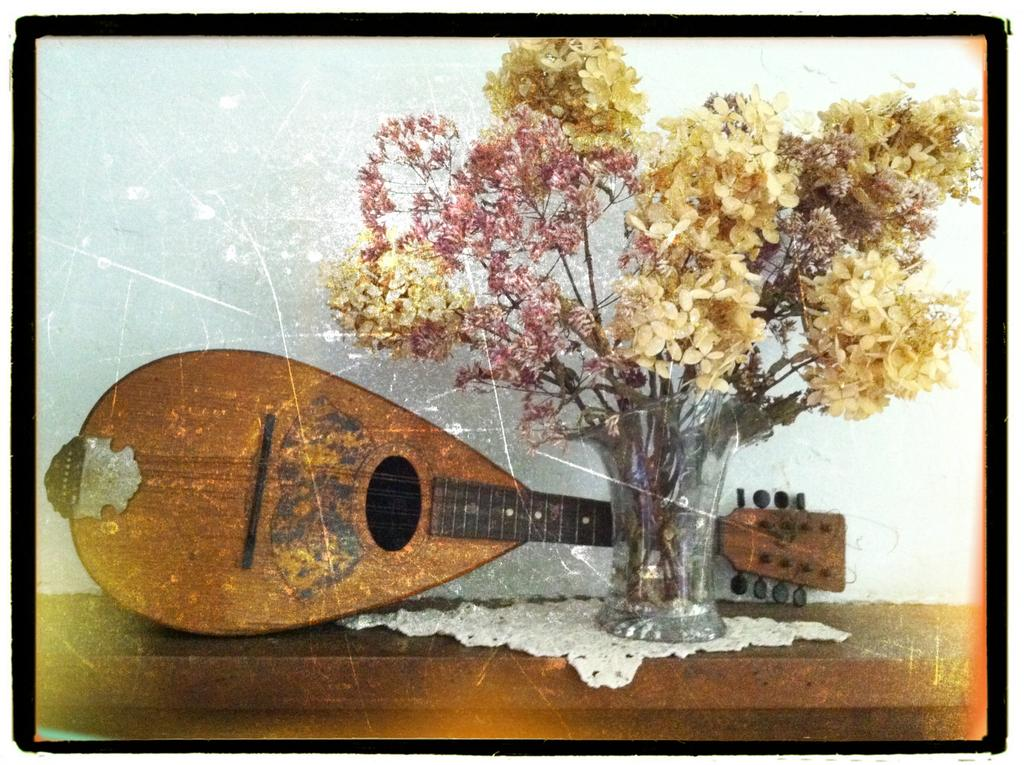What is the main object in the image? There is a guitar frame in the image. What else can be seen on the table in the image? There is a flower vase on a table in the image. What type of background is visible in the image? There is a wall visible in the image. Where are the scissors placed in the image? There are no scissors present in the image. What type of milk is being poured into the guitar frame in the image? There is no milk present in the image, and the guitar frame is not a container for pouring milk. 